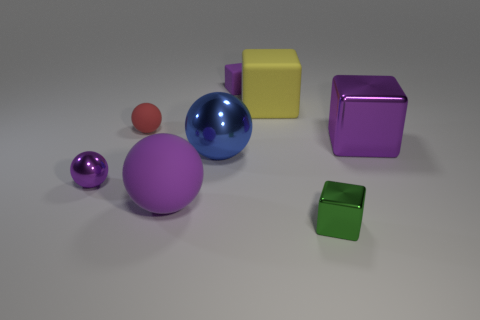What number of yellow matte things are to the right of the rubber thing that is on the left side of the rubber object that is in front of the purple metallic cube?
Make the answer very short. 1. How many big objects are either purple shiny things or yellow things?
Provide a succinct answer. 2. Does the big object that is in front of the blue ball have the same material as the green thing?
Offer a very short reply. No. The big purple object to the right of the tiny block behind the big cube that is behind the large metal block is made of what material?
Provide a short and direct response. Metal. Are there any other things that have the same size as the yellow rubber thing?
Your answer should be compact. Yes. What number of matte objects are balls or blue things?
Provide a succinct answer. 2. Are any big gray rubber cylinders visible?
Offer a very short reply. No. There is a matte thing in front of the purple metallic thing that is left of the blue metal ball; what color is it?
Make the answer very short. Purple. How many other objects are the same color as the tiny matte cube?
Make the answer very short. 3. What number of objects are either large blue balls or big metal objects that are left of the purple shiny cube?
Your response must be concise. 1. 